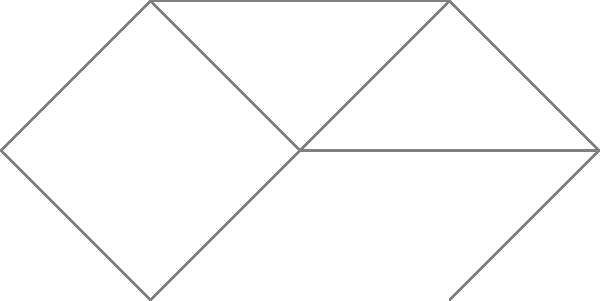You're planning a spontaneous pub crawl through a historic city center, where each vertex represents a bar and each edge represents a street connecting two bars. The weight of each edge indicates the time (in minutes) it takes to walk between the bars. What is the maximum number of unique bars you can visit if you start at bar A, have exactly 10 minutes for the crawl, and cannot revisit any street? Let's approach this step-by-step:

1) We start at bar A and have 10 minutes total.

2) The possible paths from A are:
   A -> B (2 min)
   A -> D (1 min)

3) Let's explore A -> B first:
   A -> B (2 min, 2 bars visited)
   B -> C (3 min, total 5 min, 3 bars)
   C -> F (3 min, total 8 min, 4 bars)
   We can't go further as all paths from F exceed our 10-minute limit.

4) Now, let's explore A -> D:
   A -> D (1 min, 2 bars visited)
   D -> C (2 min, total 3 min, 3 bars)
   C -> B (3 min, total 6 min, 4 bars)
   B -> E (2 min, total 8 min, 5 bars)
   E -> F (1 min, total 9 min, 6 bars)

5) The path A -> D -> C -> B -> E -> F visits 6 bars in 9 minutes, which is the maximum possible within the 10-minute limit without revisiting any street.

Therefore, the maximum number of unique bars you can visit is 6.
Answer: 6 bars 